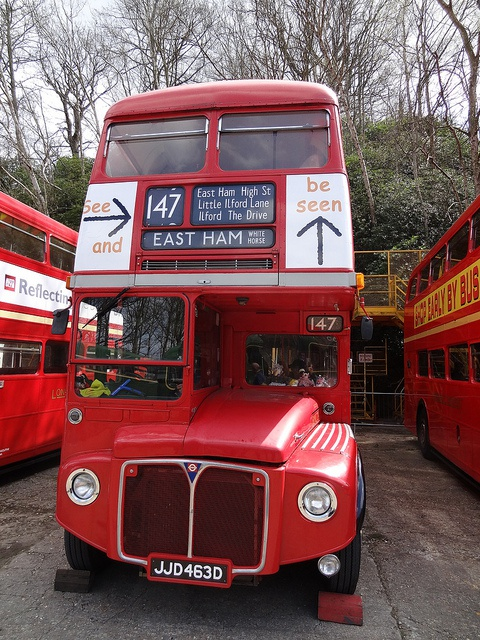Describe the objects in this image and their specific colors. I can see bus in white, black, brown, gray, and maroon tones, bus in white, brown, and black tones, and bus in white, maroon, black, and brown tones in this image. 